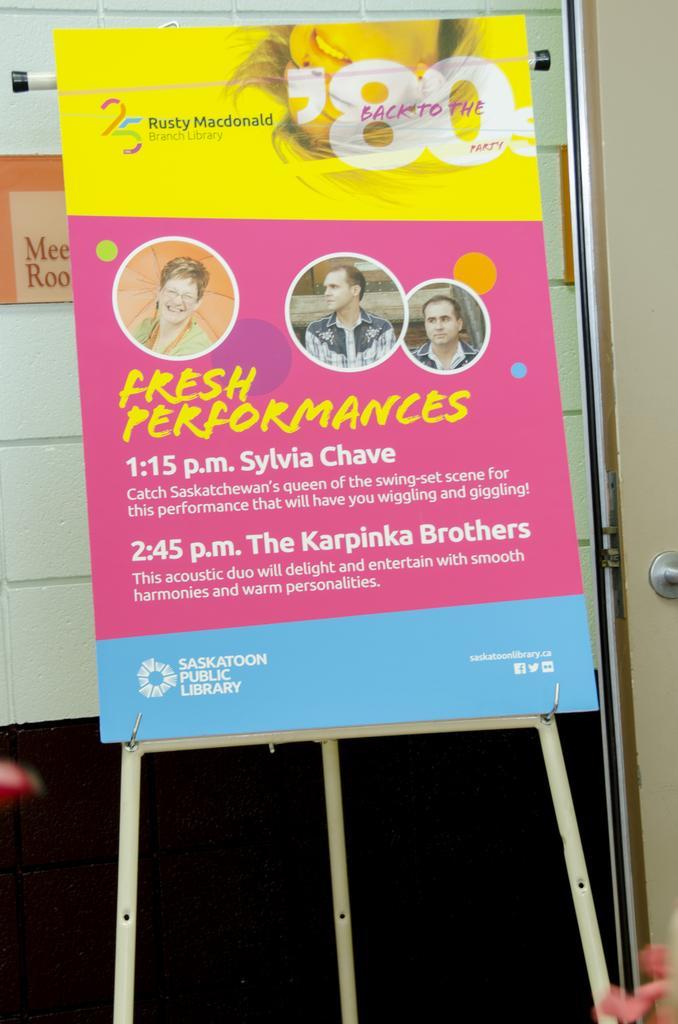Describe this image in one or two sentences. In this image I see the white stand on which there is a board and I see something is written and I see 3 pictures of persons and it is dark over here and I see something is written over here too. 